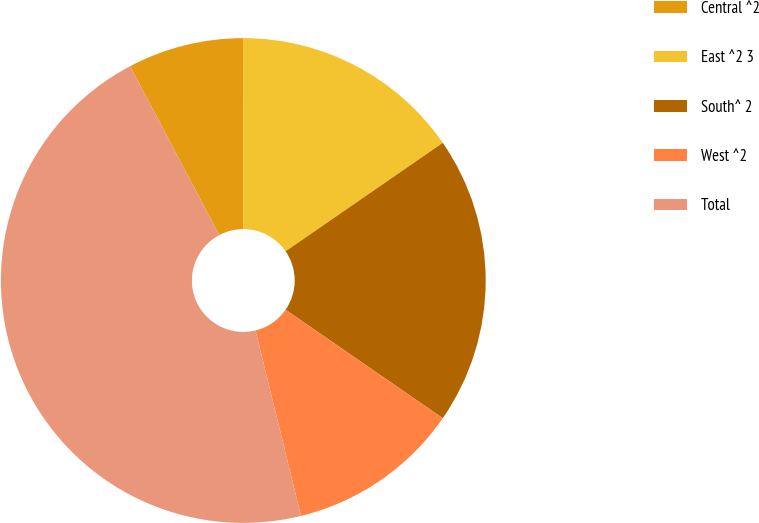Convert chart to OTSL. <chart><loc_0><loc_0><loc_500><loc_500><pie_chart><fcel>Central ^2<fcel>East ^2 3<fcel>South^ 2<fcel>West ^2<fcel>Total<nl><fcel>7.72%<fcel>15.4%<fcel>19.23%<fcel>11.56%<fcel>46.09%<nl></chart> 